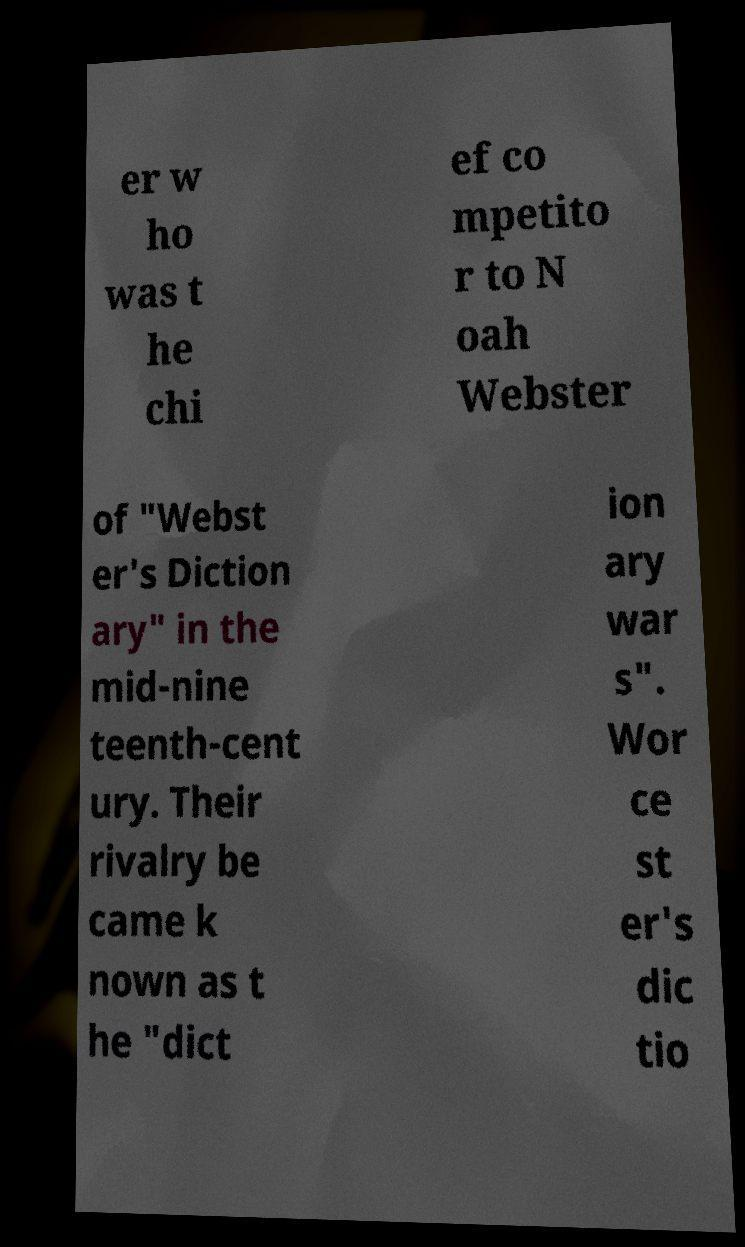Can you accurately transcribe the text from the provided image for me? er w ho was t he chi ef co mpetito r to N oah Webster of "Webst er's Diction ary" in the mid-nine teenth-cent ury. Their rivalry be came k nown as t he "dict ion ary war s". Wor ce st er's dic tio 